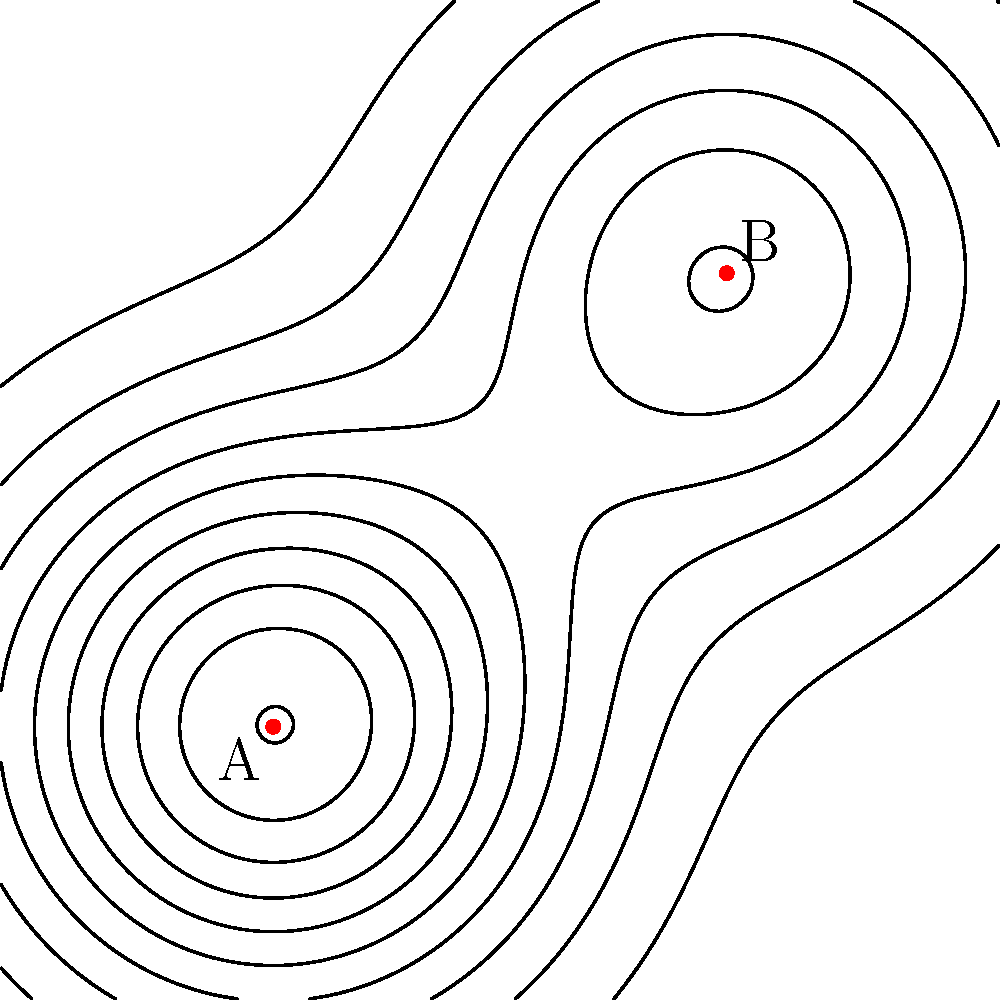Based on the topological map shown, which location (A or B) would be more suitable for establishing a wildlife rehabilitation center, considering the surrounding terrain? To determine the optimal location for a wildlife rehabilitation center, we need to analyze the topological map:

1. Interpret the contour lines:
   - Closely spaced lines indicate steeper terrain
   - Widely spaced lines indicate flatter terrain

2. Analyze location A (2,2):
   - The contour lines are more widely spaced
   - This suggests a relatively flat area

3. Analyze location B (7,7):
   - The contour lines are more closely spaced
   - This indicates steeper, more varied terrain

4. Consider the needs of a wildlife rehabilitation center:
   - Flat terrain is preferable for:
     a. Easier construction of facilities
     b. Better accessibility for vehicles and staff
     c. Creating larger, level enclosures for animals

5. Evaluate the surrounding area:
   - Location A has more consistent, flat terrain in its vicinity
   - Location B is surrounded by more varied, potentially challenging terrain

6. Make a decision:
   - Location A provides a more suitable environment for a wildlife rehabilitation center due to its flatter terrain and easier accessibility
Answer: Location A 